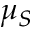<formula> <loc_0><loc_0><loc_500><loc_500>\mu _ { S }</formula> 